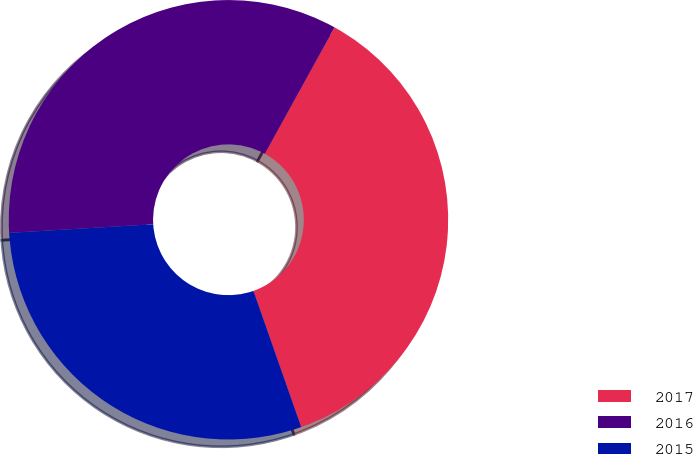Convert chart to OTSL. <chart><loc_0><loc_0><loc_500><loc_500><pie_chart><fcel>2017<fcel>2016<fcel>2015<nl><fcel>36.61%<fcel>33.97%<fcel>29.42%<nl></chart> 